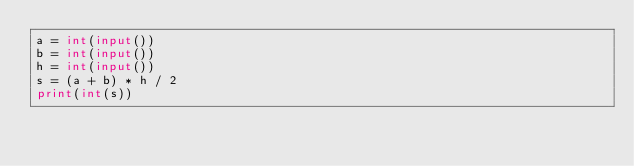Convert code to text. <code><loc_0><loc_0><loc_500><loc_500><_Python_>a = int(input())
b = int(input())
h = int(input())
s = (a + b) * h / 2
print(int(s))</code> 